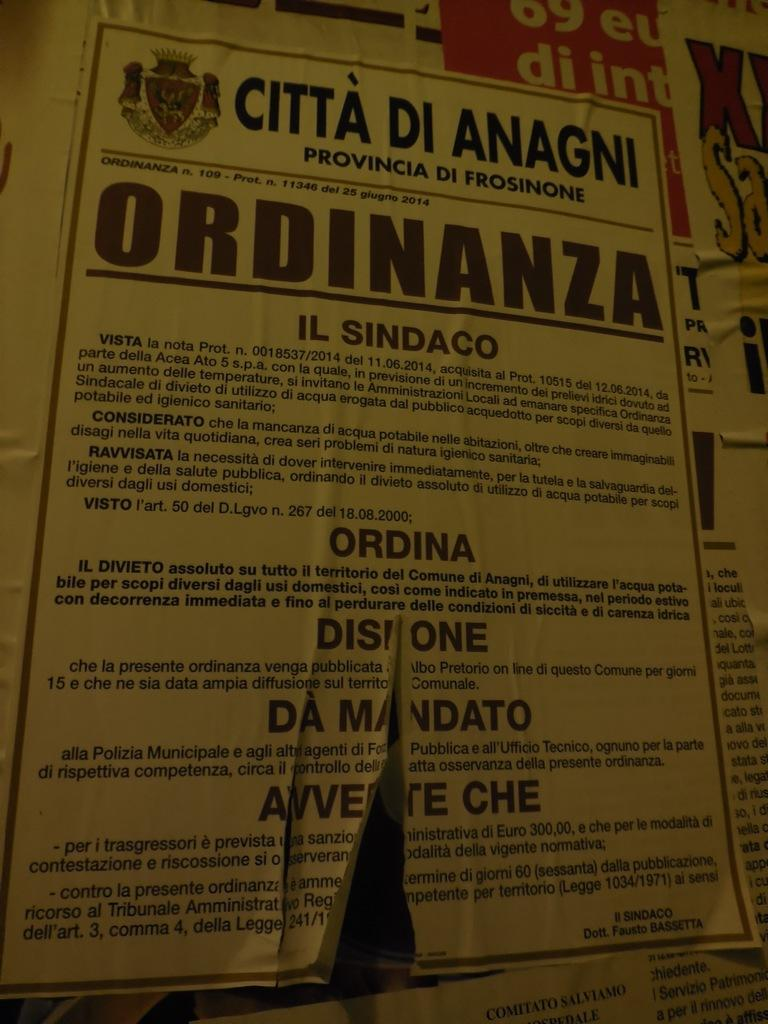<image>
Share a concise interpretation of the image provided. A flyer on a wall has the heading Citta Di Anagni. 